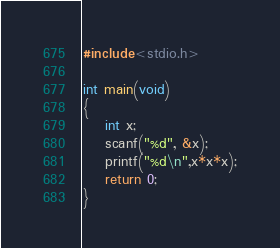<code> <loc_0><loc_0><loc_500><loc_500><_C_>#include<stdio.h>

int main(void)
{
	int x;
	scanf("%d", &x);
	printf("%d\n",x*x*x);
	return 0;
}

</code> 